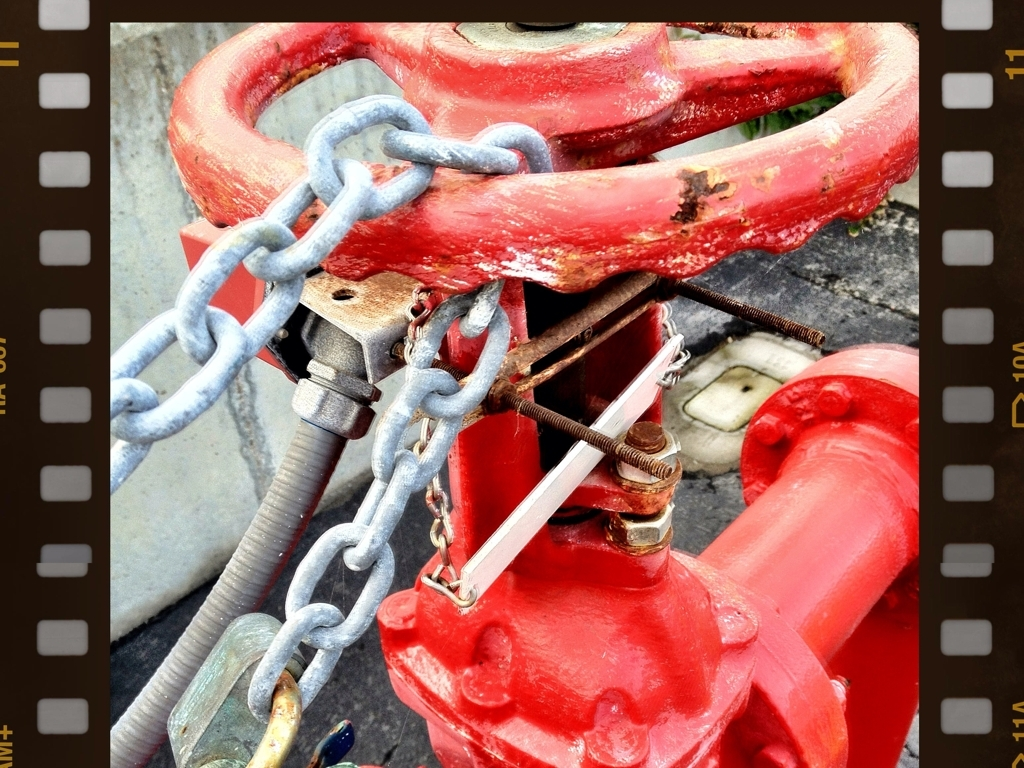What does the chain attached to the hydrant suggest about its location? The chain linked to the hydrant implies that it might be in a high-traffic area or near a location that requires securing the hydrant against unauthorized use. It's a measure often taken to prevent theft or tampering, ensuring the hydrant remains available and fully functional for emergencies. 